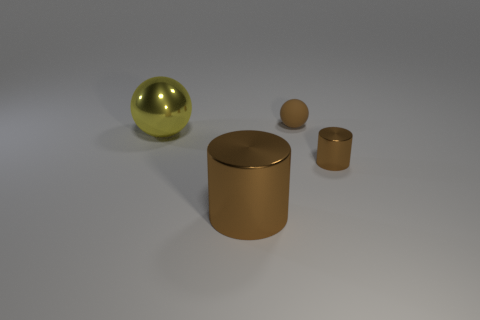What is the yellow ball made of?
Keep it short and to the point. Metal. How many objects are big spheres or brown rubber things?
Give a very brief answer. 2. What is the size of the brown cylinder that is on the right side of the brown rubber sphere?
Keep it short and to the point. Small. How many other things are made of the same material as the tiny ball?
Offer a terse response. 0. Are there any tiny balls that are in front of the tiny brown thing that is to the right of the matte object?
Your answer should be compact. No. Is there anything else that is the same shape as the brown matte object?
Provide a short and direct response. Yes. The tiny rubber thing that is the same shape as the big yellow object is what color?
Provide a short and direct response. Brown. The yellow metallic ball is what size?
Your response must be concise. Large. Are there fewer tiny brown spheres left of the tiny brown matte ball than large shiny things?
Make the answer very short. Yes. Is the big brown thing made of the same material as the small object that is behind the small brown cylinder?
Make the answer very short. No. 